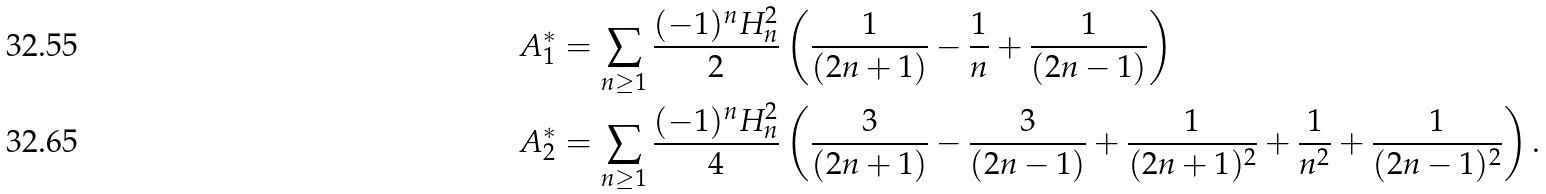<formula> <loc_0><loc_0><loc_500><loc_500>A _ { 1 } ^ { \ast } & = \sum _ { n \geq 1 } \frac { ( - 1 ) ^ { n } H _ { n } ^ { 2 } } { 2 } \left ( \frac { 1 } { ( 2 n + 1 ) } - \frac { 1 } { n } + \frac { 1 } { ( 2 n - 1 ) } \right ) \\ A _ { 2 } ^ { \ast } & = \sum _ { n \geq 1 } \frac { ( - 1 ) ^ { n } H _ { n } ^ { 2 } } { 4 } \left ( \frac { 3 } { ( 2 n + 1 ) } - \frac { 3 } { ( 2 n - 1 ) } + \frac { 1 } { ( 2 n + 1 ) ^ { 2 } } + \frac { 1 } { n ^ { 2 } } + \frac { 1 } { ( 2 n - 1 ) ^ { 2 } } \right ) .</formula> 